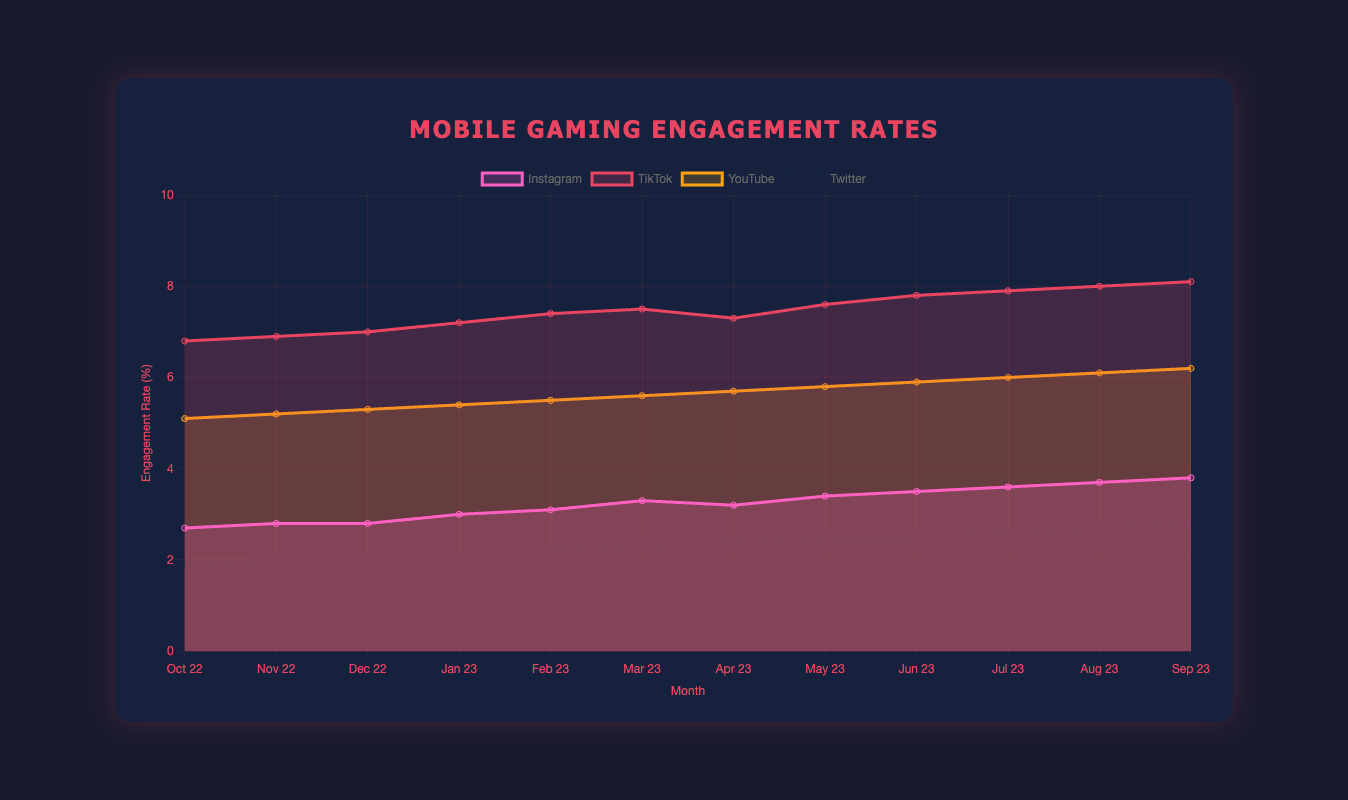What is the overall trend of TikTok's engagement rate over the past 12 months? From the data, we observe that TikTok's engagement rate starts at 6.8% in October 2022 and gradually increases almost every month, reaching 8.1% in September 2023. This consistent month-to-month increase signifies a positive upward trend in engagement rate over the observed period.
Answer: Upward trend Which platform had the highest engagement rate in September 2023? In September 2023, TikTok had the highest engagement rate at 8.1%, compared to Instagram's 3.8%, YouTube's 6.2%, and Twitter's 2.8%. Therefore, TikTok is the platform with the highest engagement rate in that month.
Answer: TikTok How does Twitter's engagement rate in March 2023 compare to its engagement rate in September 2023? In March 2023, Twitter's engagement rate was 2.3%, and in September 2023, it was 2.8%. The difference between these two values is 0.5%, indicating that Twitter's engagement rate increased by 0.5 percentage points over this period.
Answer: Increased by 0.5% Which platform had the smallest change in engagement rate from October 2022 to September 2023? To find the platform with the smallest change, we need to calculate the difference in engagement rates for each platform from October 2022 to September 2023. 
   - Instagram: 3.8% - 2.7% = 1.1%
   - TikTok: 8.1% - 6.8% = 1.3%
   - YouTube: 6.2% - 5.1% = 1.1%
   - Twitter: 2.8% - 1.9% = 0.9%
   Thus, Twitter had the smallest engagement rate change of 0.9%.
Answer: Twitter What was the average engagement rate for YouTube over the past 12 months? To calculate the average engagement rate for YouTube, sum up the monthly engagement rates and divide by the total number of months:
   (5.1 + 5.2 + 5.3 + 5.4 + 5.5 + 5.6 + 5.7 + 5.8 + 5.9 + 6.0 + 6.1 + 6.2) / 12 = 67.8 / 12 ≈ 5.65%
Answer: 5.65% In which month did Instagram experience its highest engagement rate growth? By examining the changes in the engagement rate of Instagram month-by-month, we see the following:
   - Oct 22 to Nov 22: 0.1
   - Nov 22 to Dec 22: 0.0
   - Dec 22 to Jan 23: 0.2
   - Jan 23 to Feb 23: 0.1
   - Feb 23 to Mar 23: 0.2
   - Mar 23 to Apr 23: -0.1
   - Apr 23 to May 23: 0.2
   - May 23 to Jun 23: 0.1
   - Jun 23 to Jul 23: 0.1
   - Jul 23 to Aug 23: 0.1
   - Aug 23 to Sep 23: 0.1
   Therefore, the highest growth (0.2 percentage points) happened between December 2022 to January 2023, February 2023 to March 2023, and April 2023 to May 2023.
Answer: January 2023, March 2023, May 2023 If the engagement rates are plotted as an area chart, in which month does YouTube's engagement rate cross the 6% threshold? Referring to the data, YouTube's engagement rate crosses the 6% threshold between June 2023 and July 2023. In June 2023, the rate was 5.9%, and by July 2023, it had reached 6.0%. Thus, the engagement rate crosses the 6% mark in July 2023.
Answer: July 2023 Is there any platform whose engagement rate decreased for any month? To determine this, we need to look at each platform's engagement rates month-by-month.
   - Instagram shows a decrease from March 2023 (3.3%) to April 2023 (3.2%).
   - TikTok shows a decrease from March 2023 (7.5%) to April 2023 (7.3%).
   - YouTube shows a consistent increase every month.
   - Twitter shows a consistent increase every month.
   Thus, both Instagram and TikTok experienced a month with a decreased engagement rate in this period.
Answer: Instagram, TikTok 